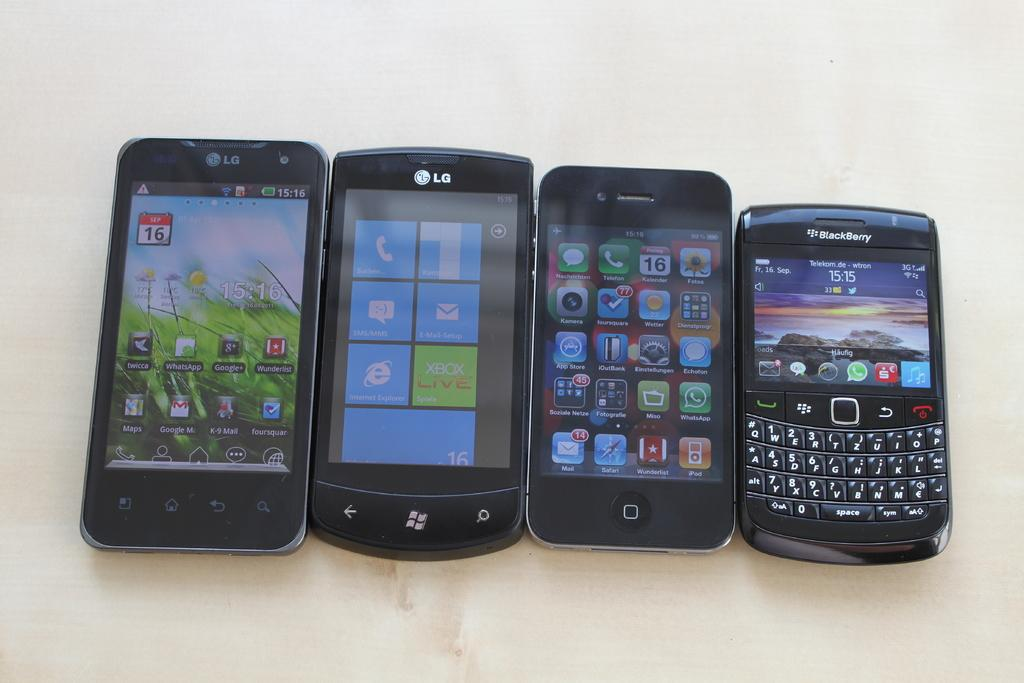<image>
Render a clear and concise summary of the photo. Two LG and a Blackberry cell phone are displayed along with an unknown cell phone brand. 